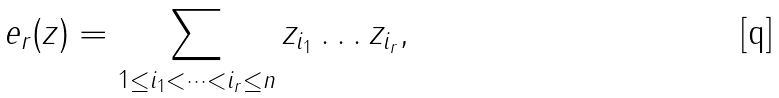<formula> <loc_0><loc_0><loc_500><loc_500>e _ { r } ( z ) = \sum _ { 1 \leq i _ { 1 } < \dots < i _ { r } \leq n } z _ { i _ { 1 } } \dots z _ { i _ { r } } ,</formula> 